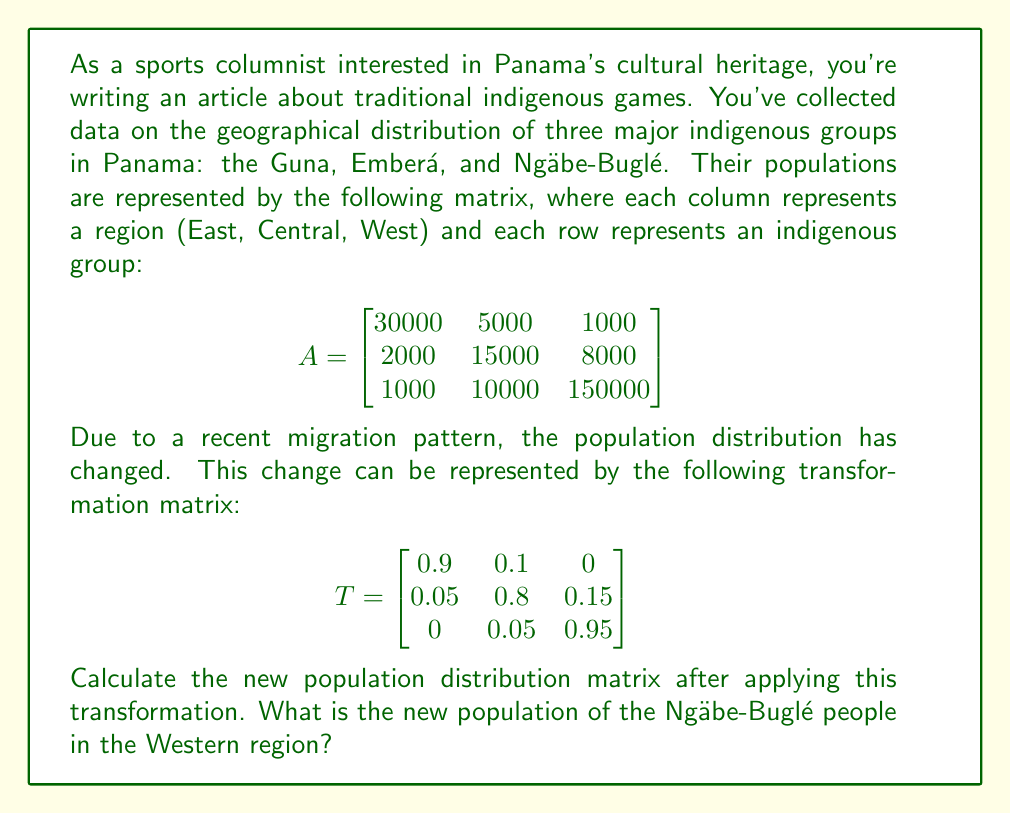Solve this math problem. To solve this problem, we need to multiply the original population matrix A by the transformation matrix T. The resulting matrix will give us the new population distribution.

Step 1: Multiply matrices A and T
$$B = A \times T$$

Step 2: Perform the matrix multiplication
$$B = \begin{bmatrix}
30000 & 5000 & 1000 \\
2000 & 15000 & 8000 \\
1000 & 10000 & 150000
\end{bmatrix} \times 
\begin{bmatrix}
0.9 & 0.1 & 0 \\
0.05 & 0.8 & 0.15 \\
0 & 0.05 & 0.95
\end{bmatrix}$$

Step 3: Calculate each element of the resulting matrix B
For example, the element in the third row and third column (representing the Ngäbe-Buglé population in the Western region) is calculated as follows:

$b_{33} = (1000 \times 0) + (10000 \times 0.15) + (150000 \times 0.95)$
$b_{33} = 0 + 1500 + 142500 = 144000$

Step 4: Complete the calculation for all elements of matrix B

$$B = \begin{bmatrix}
27750 & 7250 & 1000 \\
3350 & 13550 & 8100 \\
1500 & 9000 & 144000
\end{bmatrix}$$

The new population of the Ngäbe-Buglé people in the Western region is the element $b_{33}$, which is 144000.
Answer: 144000 